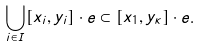Convert formula to latex. <formula><loc_0><loc_0><loc_500><loc_500>\bigcup _ { i \in I } [ x _ { i } , y _ { i } ] \cdot e \subset [ x _ { 1 } , y _ { \kappa } ] \cdot e .</formula> 